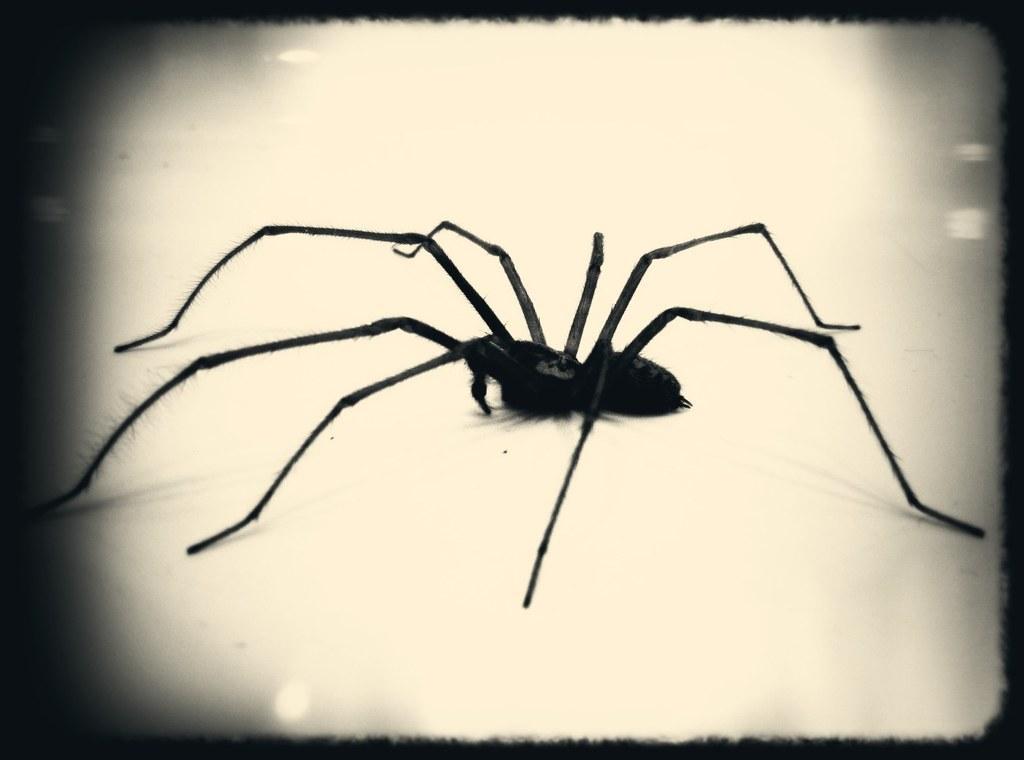Can you describe this image briefly? In this image I can see a black colored spider. 